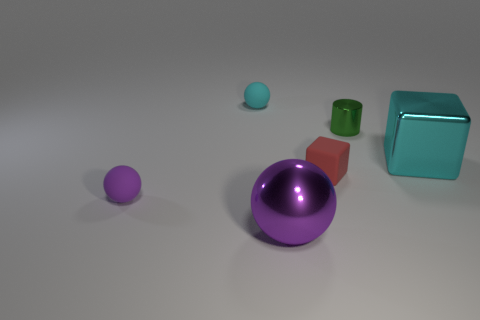Add 3 big cyan rubber cubes. How many objects exist? 9 Subtract all cylinders. How many objects are left? 5 Subtract all blue metal cylinders. Subtract all tiny green shiny things. How many objects are left? 5 Add 2 shiny cylinders. How many shiny cylinders are left? 3 Add 5 large shiny spheres. How many large shiny spheres exist? 6 Subtract 1 red blocks. How many objects are left? 5 